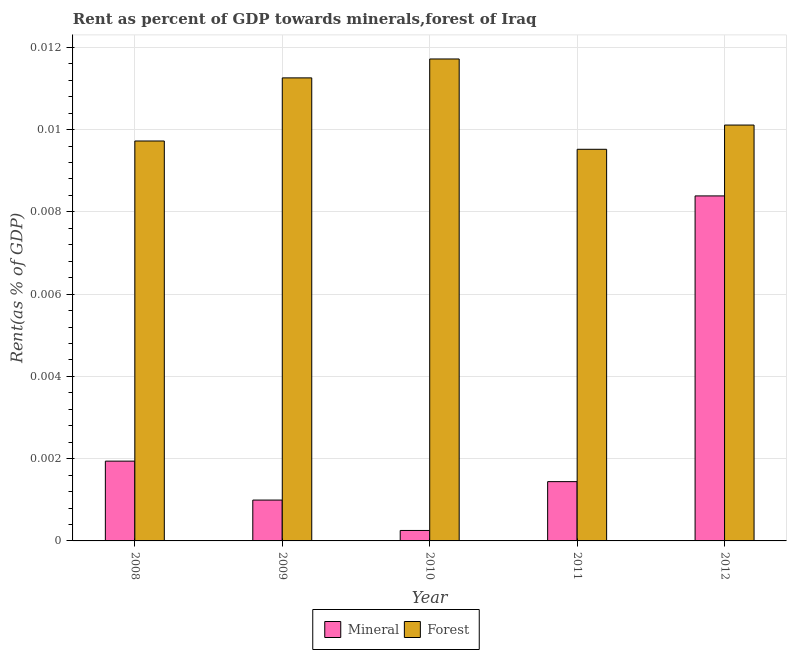How many groups of bars are there?
Provide a short and direct response. 5. Are the number of bars per tick equal to the number of legend labels?
Provide a succinct answer. Yes. How many bars are there on the 1st tick from the left?
Keep it short and to the point. 2. What is the label of the 1st group of bars from the left?
Your answer should be compact. 2008. In how many cases, is the number of bars for a given year not equal to the number of legend labels?
Offer a very short reply. 0. What is the forest rent in 2009?
Provide a succinct answer. 0.01. Across all years, what is the maximum forest rent?
Provide a succinct answer. 0.01. Across all years, what is the minimum mineral rent?
Give a very brief answer. 0. In which year was the mineral rent maximum?
Your answer should be very brief. 2012. What is the total forest rent in the graph?
Your answer should be compact. 0.05. What is the difference between the mineral rent in 2008 and that in 2011?
Provide a succinct answer. 0. What is the difference between the mineral rent in 2011 and the forest rent in 2009?
Ensure brevity in your answer.  0. What is the average mineral rent per year?
Provide a succinct answer. 0. What is the ratio of the mineral rent in 2009 to that in 2012?
Give a very brief answer. 0.12. Is the forest rent in 2010 less than that in 2012?
Give a very brief answer. No. What is the difference between the highest and the second highest mineral rent?
Ensure brevity in your answer.  0.01. What is the difference between the highest and the lowest mineral rent?
Your answer should be compact. 0.01. Is the sum of the forest rent in 2009 and 2011 greater than the maximum mineral rent across all years?
Your answer should be very brief. Yes. What does the 2nd bar from the left in 2009 represents?
Make the answer very short. Forest. What does the 1st bar from the right in 2012 represents?
Offer a terse response. Forest. How many years are there in the graph?
Your answer should be very brief. 5. What is the difference between two consecutive major ticks on the Y-axis?
Provide a short and direct response. 0. Are the values on the major ticks of Y-axis written in scientific E-notation?
Offer a terse response. No. Does the graph contain grids?
Provide a succinct answer. Yes. Where does the legend appear in the graph?
Offer a very short reply. Bottom center. What is the title of the graph?
Your answer should be very brief. Rent as percent of GDP towards minerals,forest of Iraq. Does "Underweight" appear as one of the legend labels in the graph?
Your answer should be very brief. No. What is the label or title of the Y-axis?
Your answer should be compact. Rent(as % of GDP). What is the Rent(as % of GDP) of Mineral in 2008?
Provide a short and direct response. 0. What is the Rent(as % of GDP) in Forest in 2008?
Keep it short and to the point. 0.01. What is the Rent(as % of GDP) in Mineral in 2009?
Offer a very short reply. 0. What is the Rent(as % of GDP) of Forest in 2009?
Make the answer very short. 0.01. What is the Rent(as % of GDP) in Mineral in 2010?
Provide a succinct answer. 0. What is the Rent(as % of GDP) in Forest in 2010?
Make the answer very short. 0.01. What is the Rent(as % of GDP) of Mineral in 2011?
Provide a succinct answer. 0. What is the Rent(as % of GDP) of Forest in 2011?
Offer a very short reply. 0.01. What is the Rent(as % of GDP) in Mineral in 2012?
Your answer should be compact. 0.01. What is the Rent(as % of GDP) of Forest in 2012?
Your answer should be compact. 0.01. Across all years, what is the maximum Rent(as % of GDP) of Mineral?
Your answer should be compact. 0.01. Across all years, what is the maximum Rent(as % of GDP) of Forest?
Provide a succinct answer. 0.01. Across all years, what is the minimum Rent(as % of GDP) of Mineral?
Offer a very short reply. 0. Across all years, what is the minimum Rent(as % of GDP) of Forest?
Give a very brief answer. 0.01. What is the total Rent(as % of GDP) in Mineral in the graph?
Give a very brief answer. 0.01. What is the total Rent(as % of GDP) in Forest in the graph?
Provide a short and direct response. 0.05. What is the difference between the Rent(as % of GDP) of Mineral in 2008 and that in 2009?
Offer a terse response. 0. What is the difference between the Rent(as % of GDP) in Forest in 2008 and that in 2009?
Ensure brevity in your answer.  -0. What is the difference between the Rent(as % of GDP) of Mineral in 2008 and that in 2010?
Provide a succinct answer. 0. What is the difference between the Rent(as % of GDP) of Forest in 2008 and that in 2010?
Provide a short and direct response. -0. What is the difference between the Rent(as % of GDP) in Mineral in 2008 and that in 2011?
Offer a terse response. 0. What is the difference between the Rent(as % of GDP) of Forest in 2008 and that in 2011?
Offer a very short reply. 0. What is the difference between the Rent(as % of GDP) of Mineral in 2008 and that in 2012?
Your response must be concise. -0.01. What is the difference between the Rent(as % of GDP) of Forest in 2008 and that in 2012?
Your answer should be very brief. -0. What is the difference between the Rent(as % of GDP) in Mineral in 2009 and that in 2010?
Your answer should be compact. 0. What is the difference between the Rent(as % of GDP) of Forest in 2009 and that in 2010?
Your response must be concise. -0. What is the difference between the Rent(as % of GDP) in Mineral in 2009 and that in 2011?
Ensure brevity in your answer.  -0. What is the difference between the Rent(as % of GDP) in Forest in 2009 and that in 2011?
Provide a short and direct response. 0. What is the difference between the Rent(as % of GDP) in Mineral in 2009 and that in 2012?
Provide a succinct answer. -0.01. What is the difference between the Rent(as % of GDP) in Forest in 2009 and that in 2012?
Your response must be concise. 0. What is the difference between the Rent(as % of GDP) of Mineral in 2010 and that in 2011?
Provide a short and direct response. -0. What is the difference between the Rent(as % of GDP) in Forest in 2010 and that in 2011?
Offer a terse response. 0. What is the difference between the Rent(as % of GDP) in Mineral in 2010 and that in 2012?
Provide a short and direct response. -0.01. What is the difference between the Rent(as % of GDP) of Forest in 2010 and that in 2012?
Make the answer very short. 0. What is the difference between the Rent(as % of GDP) in Mineral in 2011 and that in 2012?
Offer a very short reply. -0.01. What is the difference between the Rent(as % of GDP) in Forest in 2011 and that in 2012?
Ensure brevity in your answer.  -0. What is the difference between the Rent(as % of GDP) in Mineral in 2008 and the Rent(as % of GDP) in Forest in 2009?
Make the answer very short. -0.01. What is the difference between the Rent(as % of GDP) in Mineral in 2008 and the Rent(as % of GDP) in Forest in 2010?
Provide a succinct answer. -0.01. What is the difference between the Rent(as % of GDP) of Mineral in 2008 and the Rent(as % of GDP) of Forest in 2011?
Offer a terse response. -0.01. What is the difference between the Rent(as % of GDP) of Mineral in 2008 and the Rent(as % of GDP) of Forest in 2012?
Provide a short and direct response. -0.01. What is the difference between the Rent(as % of GDP) of Mineral in 2009 and the Rent(as % of GDP) of Forest in 2010?
Your answer should be very brief. -0.01. What is the difference between the Rent(as % of GDP) of Mineral in 2009 and the Rent(as % of GDP) of Forest in 2011?
Ensure brevity in your answer.  -0.01. What is the difference between the Rent(as % of GDP) in Mineral in 2009 and the Rent(as % of GDP) in Forest in 2012?
Give a very brief answer. -0.01. What is the difference between the Rent(as % of GDP) in Mineral in 2010 and the Rent(as % of GDP) in Forest in 2011?
Your response must be concise. -0.01. What is the difference between the Rent(as % of GDP) of Mineral in 2010 and the Rent(as % of GDP) of Forest in 2012?
Provide a short and direct response. -0.01. What is the difference between the Rent(as % of GDP) in Mineral in 2011 and the Rent(as % of GDP) in Forest in 2012?
Give a very brief answer. -0.01. What is the average Rent(as % of GDP) of Mineral per year?
Your response must be concise. 0. What is the average Rent(as % of GDP) of Forest per year?
Keep it short and to the point. 0.01. In the year 2008, what is the difference between the Rent(as % of GDP) in Mineral and Rent(as % of GDP) in Forest?
Keep it short and to the point. -0.01. In the year 2009, what is the difference between the Rent(as % of GDP) of Mineral and Rent(as % of GDP) of Forest?
Your answer should be compact. -0.01. In the year 2010, what is the difference between the Rent(as % of GDP) in Mineral and Rent(as % of GDP) in Forest?
Your response must be concise. -0.01. In the year 2011, what is the difference between the Rent(as % of GDP) of Mineral and Rent(as % of GDP) of Forest?
Your answer should be very brief. -0.01. In the year 2012, what is the difference between the Rent(as % of GDP) in Mineral and Rent(as % of GDP) in Forest?
Your response must be concise. -0. What is the ratio of the Rent(as % of GDP) in Mineral in 2008 to that in 2009?
Your response must be concise. 1.95. What is the ratio of the Rent(as % of GDP) in Forest in 2008 to that in 2009?
Keep it short and to the point. 0.86. What is the ratio of the Rent(as % of GDP) in Mineral in 2008 to that in 2010?
Make the answer very short. 7.63. What is the ratio of the Rent(as % of GDP) of Forest in 2008 to that in 2010?
Provide a succinct answer. 0.83. What is the ratio of the Rent(as % of GDP) of Mineral in 2008 to that in 2011?
Give a very brief answer. 1.35. What is the ratio of the Rent(as % of GDP) of Forest in 2008 to that in 2011?
Your answer should be compact. 1.02. What is the ratio of the Rent(as % of GDP) of Mineral in 2008 to that in 2012?
Your answer should be very brief. 0.23. What is the ratio of the Rent(as % of GDP) of Forest in 2008 to that in 2012?
Make the answer very short. 0.96. What is the ratio of the Rent(as % of GDP) of Mineral in 2009 to that in 2010?
Offer a very short reply. 3.91. What is the ratio of the Rent(as % of GDP) in Forest in 2009 to that in 2010?
Your answer should be very brief. 0.96. What is the ratio of the Rent(as % of GDP) of Mineral in 2009 to that in 2011?
Give a very brief answer. 0.69. What is the ratio of the Rent(as % of GDP) of Forest in 2009 to that in 2011?
Your response must be concise. 1.18. What is the ratio of the Rent(as % of GDP) of Mineral in 2009 to that in 2012?
Offer a very short reply. 0.12. What is the ratio of the Rent(as % of GDP) in Forest in 2009 to that in 2012?
Give a very brief answer. 1.11. What is the ratio of the Rent(as % of GDP) in Mineral in 2010 to that in 2011?
Ensure brevity in your answer.  0.18. What is the ratio of the Rent(as % of GDP) of Forest in 2010 to that in 2011?
Your response must be concise. 1.23. What is the ratio of the Rent(as % of GDP) of Mineral in 2010 to that in 2012?
Offer a very short reply. 0.03. What is the ratio of the Rent(as % of GDP) in Forest in 2010 to that in 2012?
Offer a very short reply. 1.16. What is the ratio of the Rent(as % of GDP) of Mineral in 2011 to that in 2012?
Make the answer very short. 0.17. What is the ratio of the Rent(as % of GDP) in Forest in 2011 to that in 2012?
Keep it short and to the point. 0.94. What is the difference between the highest and the second highest Rent(as % of GDP) in Mineral?
Offer a terse response. 0.01. What is the difference between the highest and the lowest Rent(as % of GDP) of Mineral?
Make the answer very short. 0.01. What is the difference between the highest and the lowest Rent(as % of GDP) in Forest?
Offer a very short reply. 0. 